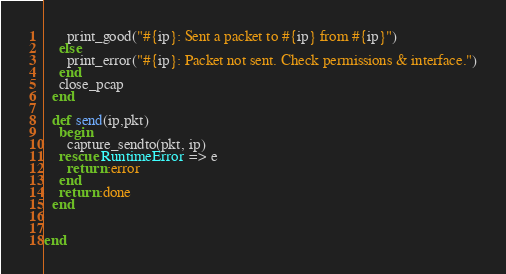<code> <loc_0><loc_0><loc_500><loc_500><_Ruby_>      print_good("#{ip}: Sent a packet to #{ip} from #{ip}")
    else
      print_error("#{ip}: Packet not sent. Check permissions & interface.")
    end
    close_pcap
  end

  def send(ip,pkt)
    begin
      capture_sendto(pkt, ip)
    rescue RuntimeError => e
      return :error
    end
    return :done
  end


end
</code> 